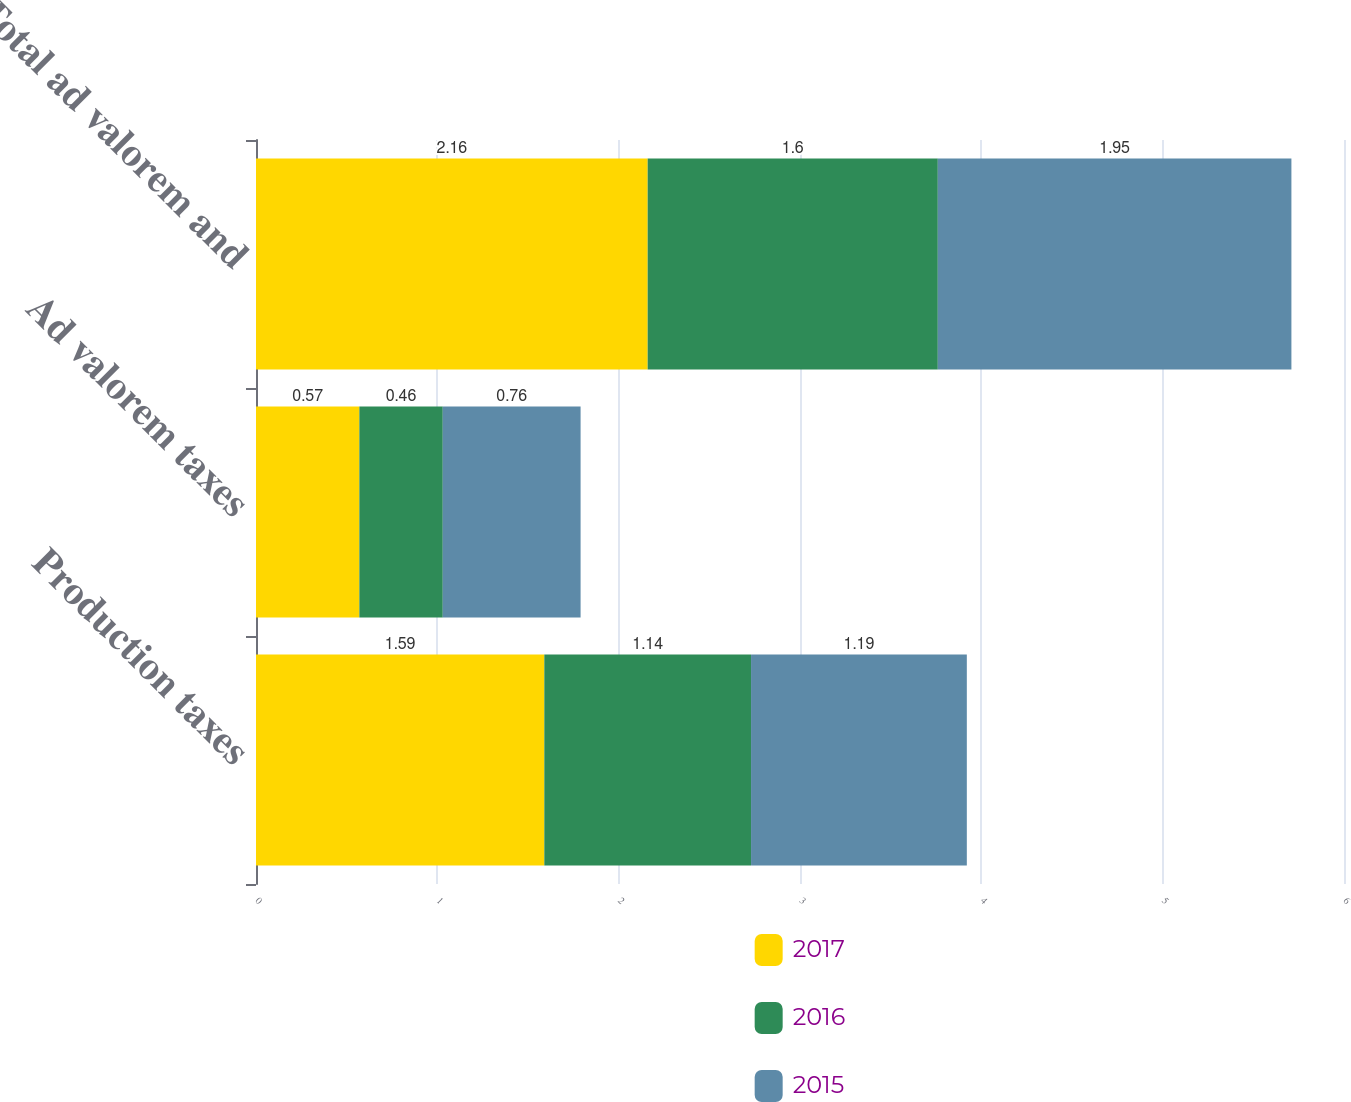<chart> <loc_0><loc_0><loc_500><loc_500><stacked_bar_chart><ecel><fcel>Production taxes<fcel>Ad valorem taxes<fcel>Total ad valorem and<nl><fcel>2017<fcel>1.59<fcel>0.57<fcel>2.16<nl><fcel>2016<fcel>1.14<fcel>0.46<fcel>1.6<nl><fcel>2015<fcel>1.19<fcel>0.76<fcel>1.95<nl></chart> 